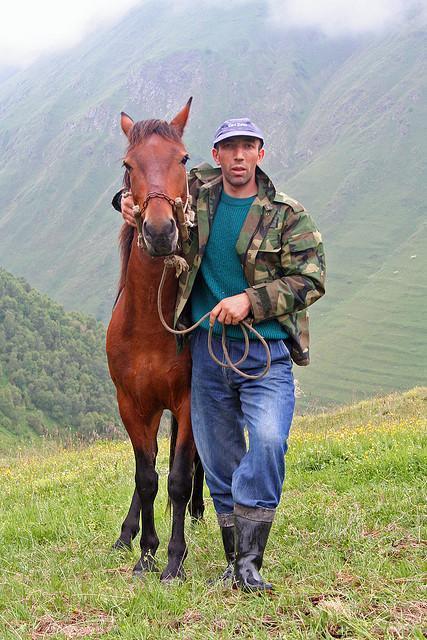How many people are present?
Give a very brief answer. 1. 